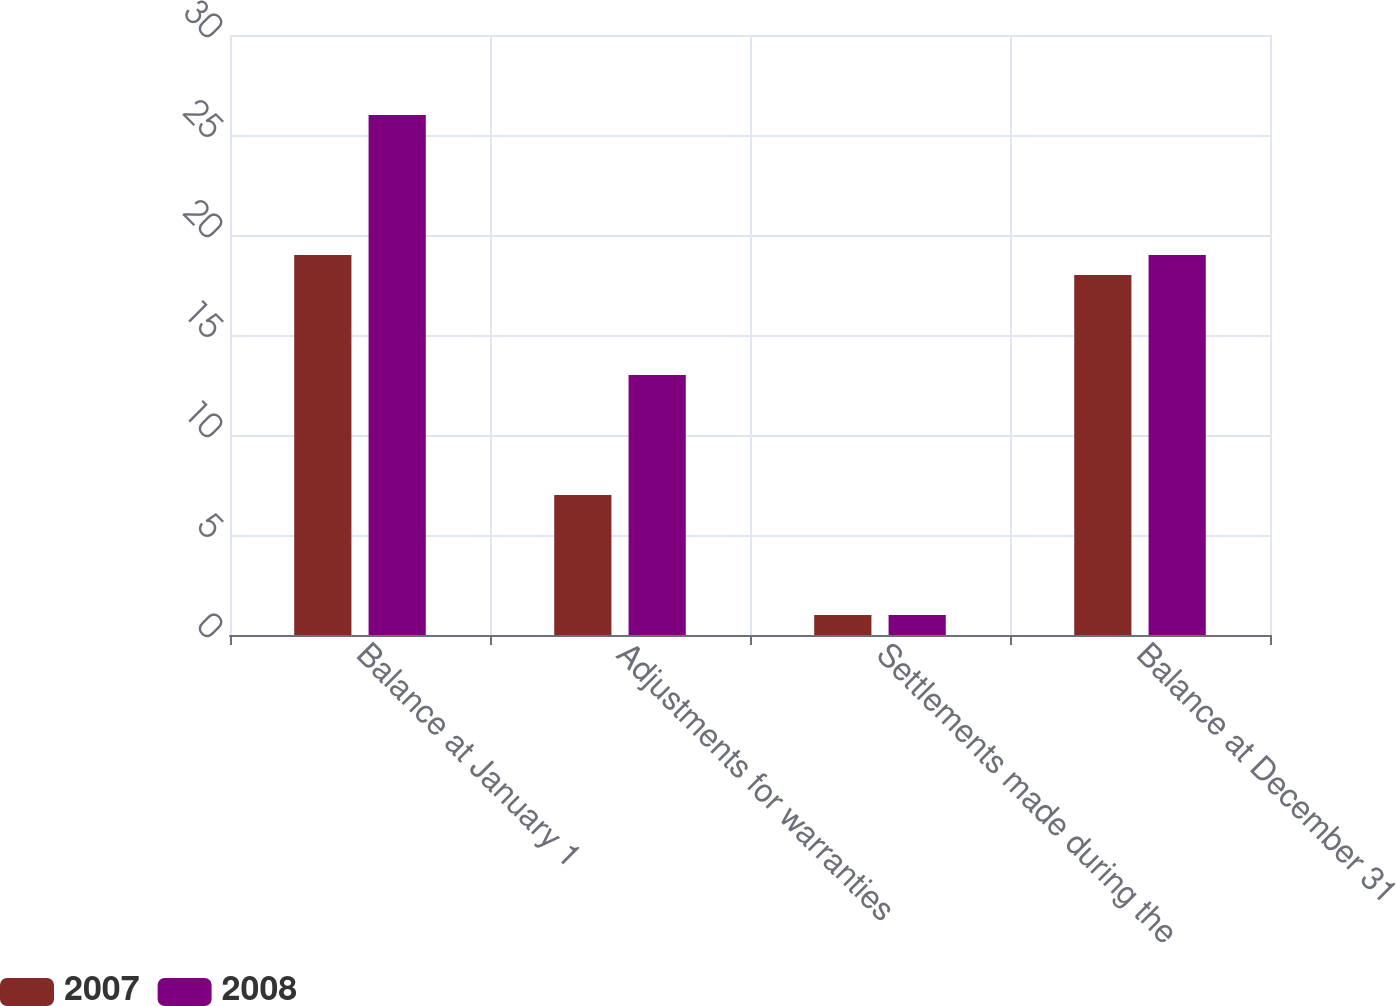<chart> <loc_0><loc_0><loc_500><loc_500><stacked_bar_chart><ecel><fcel>Balance at January 1<fcel>Adjustments for warranties<fcel>Settlements made during the<fcel>Balance at December 31<nl><fcel>2007<fcel>19<fcel>7<fcel>1<fcel>18<nl><fcel>2008<fcel>26<fcel>13<fcel>1<fcel>19<nl></chart> 